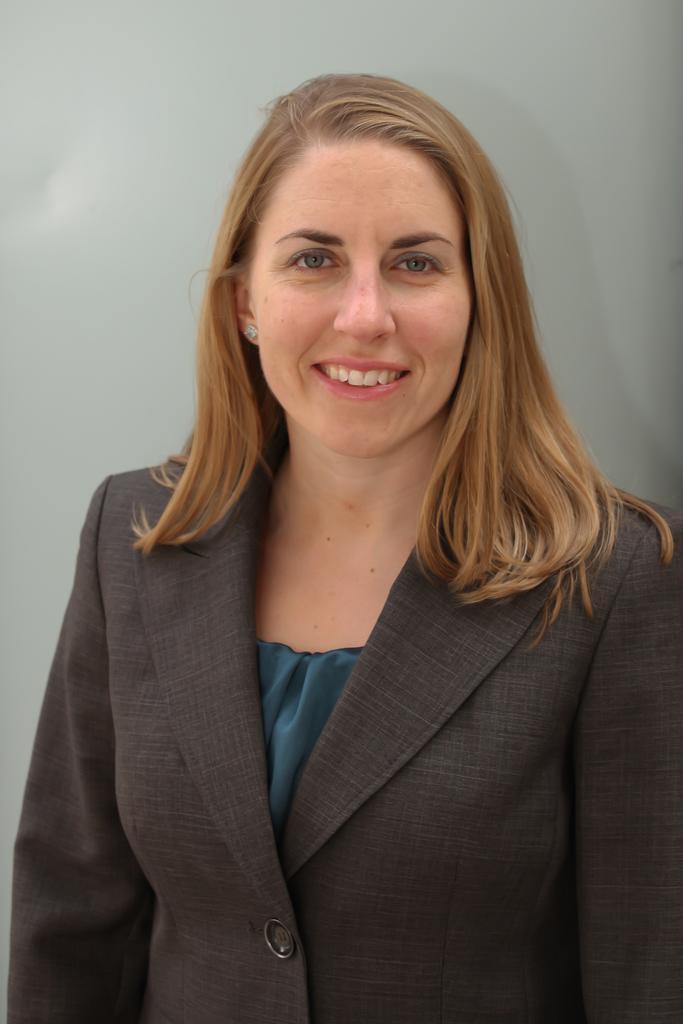How would you summarize this image in a sentence or two? In this image I can see a woman and I can see smile on her face. I can also see she is wearing formal dress. 